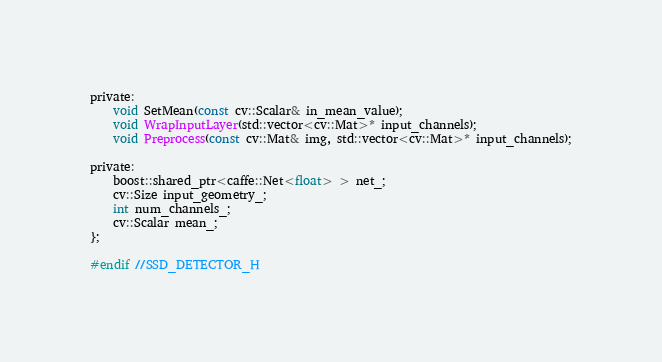<code> <loc_0><loc_0><loc_500><loc_500><_C_>
private:
	void SetMean(const cv::Scalar& in_mean_value);
	void WrapInputLayer(std::vector<cv::Mat>* input_channels);
	void Preprocess(const cv::Mat& img, std::vector<cv::Mat>* input_channels);

private:
	boost::shared_ptr<caffe::Net<float> > net_;
	cv::Size input_geometry_;
	int num_channels_;
	cv::Scalar mean_;
};

#endif //SSD_DETECTOR_H
</code> 